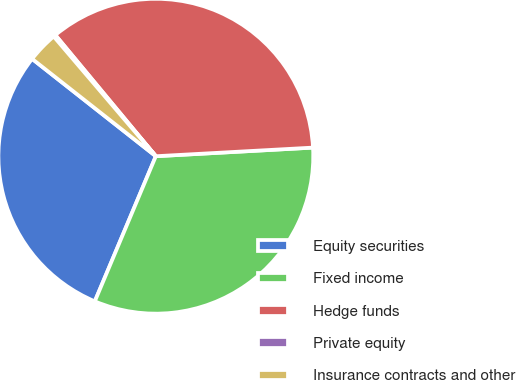Convert chart. <chart><loc_0><loc_0><loc_500><loc_500><pie_chart><fcel>Equity securities<fcel>Fixed income<fcel>Hedge funds<fcel>Private equity<fcel>Insurance contracts and other<nl><fcel>29.28%<fcel>32.21%<fcel>35.15%<fcel>0.22%<fcel>3.15%<nl></chart> 